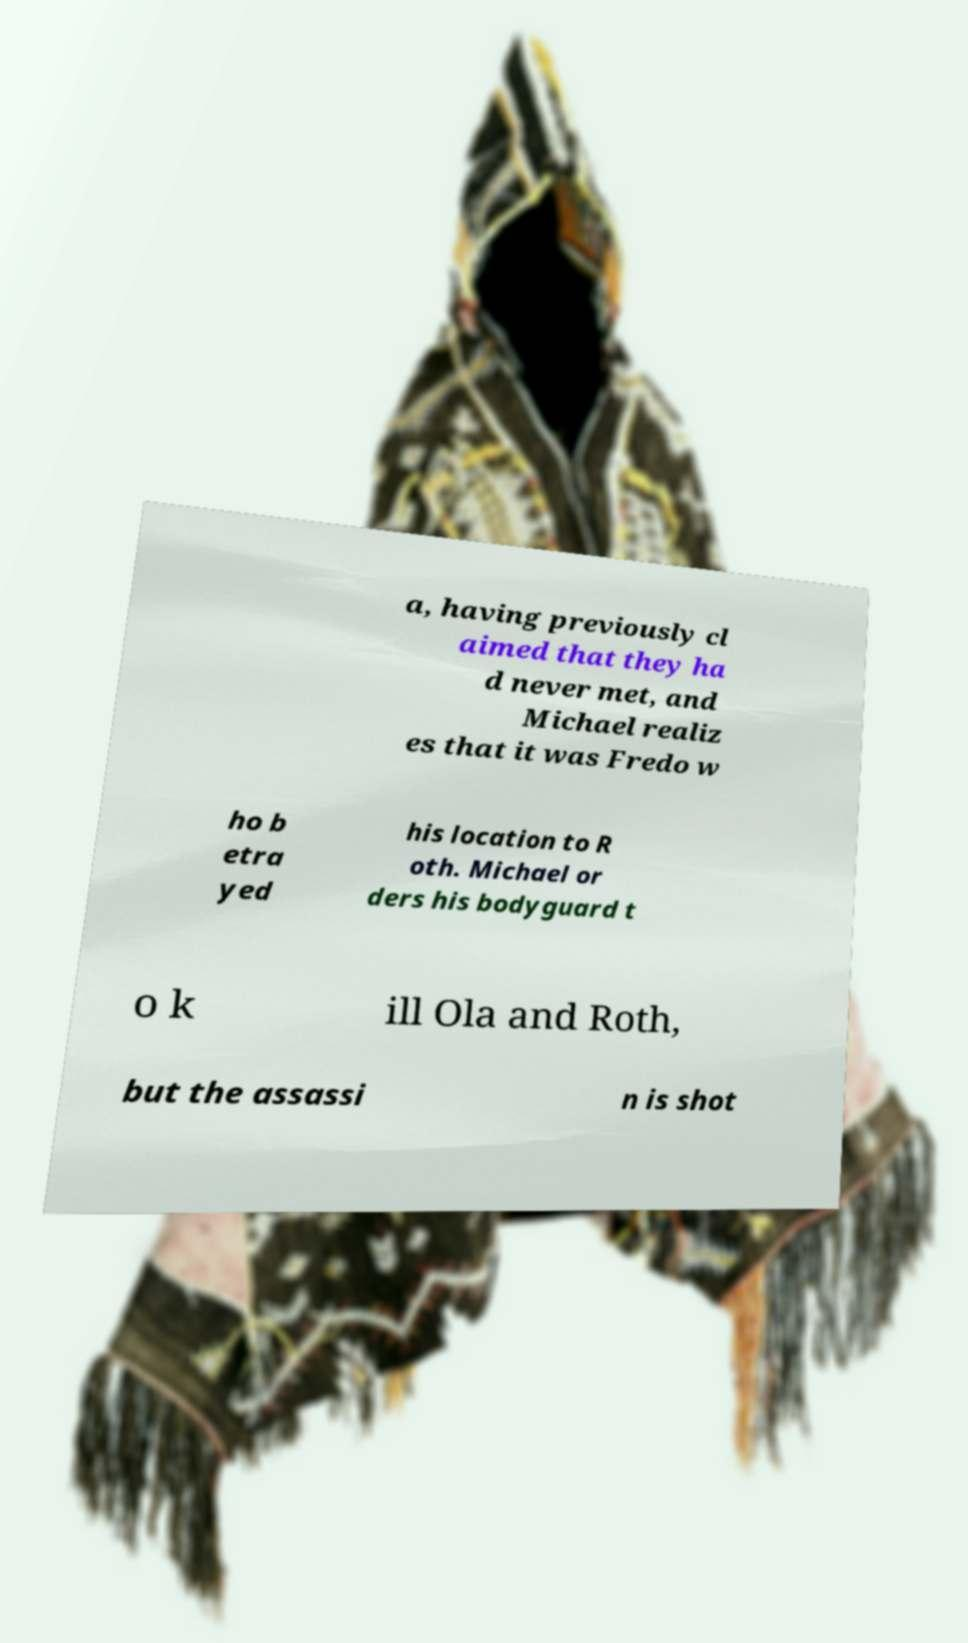Could you assist in decoding the text presented in this image and type it out clearly? a, having previously cl aimed that they ha d never met, and Michael realiz es that it was Fredo w ho b etra yed his location to R oth. Michael or ders his bodyguard t o k ill Ola and Roth, but the assassi n is shot 